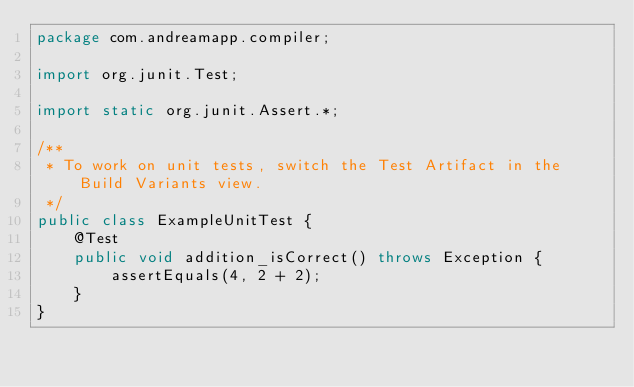<code> <loc_0><loc_0><loc_500><loc_500><_Java_>package com.andreamapp.compiler;

import org.junit.Test;

import static org.junit.Assert.*;

/**
 * To work on unit tests, switch the Test Artifact in the Build Variants view.
 */
public class ExampleUnitTest {
    @Test
    public void addition_isCorrect() throws Exception {
        assertEquals(4, 2 + 2);
    }
}</code> 